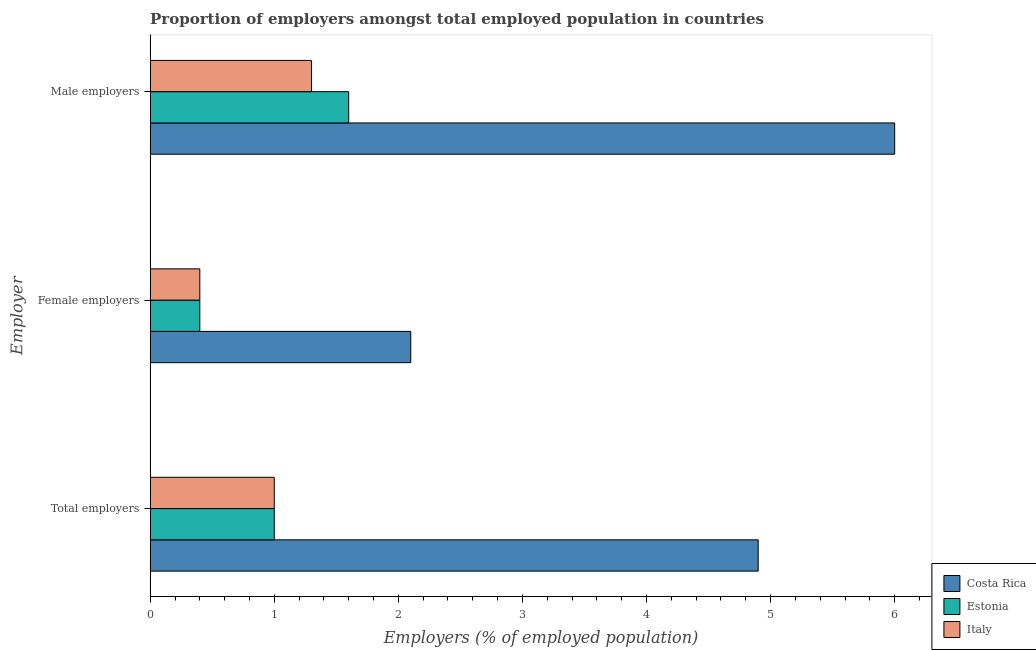How many different coloured bars are there?
Your response must be concise. 3. How many bars are there on the 2nd tick from the bottom?
Your answer should be very brief. 3. What is the label of the 1st group of bars from the top?
Your response must be concise. Male employers. What is the percentage of female employers in Estonia?
Your answer should be very brief. 0.4. Across all countries, what is the maximum percentage of female employers?
Keep it short and to the point. 2.1. Across all countries, what is the minimum percentage of male employers?
Ensure brevity in your answer.  1.3. In which country was the percentage of female employers maximum?
Offer a terse response. Costa Rica. In which country was the percentage of female employers minimum?
Offer a terse response. Estonia. What is the total percentage of male employers in the graph?
Keep it short and to the point. 8.9. What is the difference between the percentage of male employers in Italy and that in Estonia?
Ensure brevity in your answer.  -0.3. What is the difference between the percentage of female employers in Estonia and the percentage of male employers in Costa Rica?
Provide a short and direct response. -5.6. What is the average percentage of female employers per country?
Offer a terse response. 0.97. What is the difference between the percentage of total employers and percentage of female employers in Estonia?
Offer a terse response. 0.6. What is the difference between the highest and the second highest percentage of male employers?
Provide a succinct answer. 4.4. What is the difference between the highest and the lowest percentage of total employers?
Make the answer very short. 3.9. In how many countries, is the percentage of female employers greater than the average percentage of female employers taken over all countries?
Keep it short and to the point. 1. Is the sum of the percentage of female employers in Estonia and Costa Rica greater than the maximum percentage of total employers across all countries?
Provide a succinct answer. No. What does the 3rd bar from the top in Total employers represents?
Ensure brevity in your answer.  Costa Rica. What does the 2nd bar from the bottom in Total employers represents?
Give a very brief answer. Estonia. Are all the bars in the graph horizontal?
Keep it short and to the point. Yes. How many countries are there in the graph?
Your answer should be compact. 3. What is the difference between two consecutive major ticks on the X-axis?
Offer a terse response. 1. Are the values on the major ticks of X-axis written in scientific E-notation?
Offer a very short reply. No. Does the graph contain any zero values?
Your answer should be compact. No. Does the graph contain grids?
Provide a succinct answer. No. How many legend labels are there?
Ensure brevity in your answer.  3. What is the title of the graph?
Your answer should be very brief. Proportion of employers amongst total employed population in countries. Does "Tuvalu" appear as one of the legend labels in the graph?
Keep it short and to the point. No. What is the label or title of the X-axis?
Provide a succinct answer. Employers (% of employed population). What is the label or title of the Y-axis?
Your response must be concise. Employer. What is the Employers (% of employed population) in Costa Rica in Total employers?
Your answer should be very brief. 4.9. What is the Employers (% of employed population) of Costa Rica in Female employers?
Your answer should be compact. 2.1. What is the Employers (% of employed population) of Estonia in Female employers?
Make the answer very short. 0.4. What is the Employers (% of employed population) in Italy in Female employers?
Offer a very short reply. 0.4. What is the Employers (% of employed population) of Estonia in Male employers?
Your answer should be very brief. 1.6. What is the Employers (% of employed population) of Italy in Male employers?
Your answer should be compact. 1.3. Across all Employer, what is the maximum Employers (% of employed population) in Estonia?
Keep it short and to the point. 1.6. Across all Employer, what is the maximum Employers (% of employed population) in Italy?
Make the answer very short. 1.3. Across all Employer, what is the minimum Employers (% of employed population) in Costa Rica?
Your answer should be compact. 2.1. Across all Employer, what is the minimum Employers (% of employed population) of Estonia?
Provide a succinct answer. 0.4. Across all Employer, what is the minimum Employers (% of employed population) of Italy?
Give a very brief answer. 0.4. What is the total Employers (% of employed population) in Estonia in the graph?
Give a very brief answer. 3. What is the total Employers (% of employed population) in Italy in the graph?
Provide a short and direct response. 2.7. What is the difference between the Employers (% of employed population) of Estonia in Total employers and that in Female employers?
Offer a very short reply. 0.6. What is the difference between the Employers (% of employed population) in Italy in Total employers and that in Female employers?
Offer a terse response. 0.6. What is the difference between the Employers (% of employed population) of Costa Rica in Total employers and that in Male employers?
Give a very brief answer. -1.1. What is the difference between the Employers (% of employed population) of Estonia in Female employers and that in Male employers?
Provide a short and direct response. -1.2. What is the difference between the Employers (% of employed population) of Italy in Female employers and that in Male employers?
Give a very brief answer. -0.9. What is the difference between the Employers (% of employed population) in Costa Rica in Total employers and the Employers (% of employed population) in Estonia in Female employers?
Offer a terse response. 4.5. What is the difference between the Employers (% of employed population) of Estonia in Total employers and the Employers (% of employed population) of Italy in Female employers?
Ensure brevity in your answer.  0.6. What is the difference between the Employers (% of employed population) in Estonia in Total employers and the Employers (% of employed population) in Italy in Male employers?
Your answer should be compact. -0.3. What is the difference between the Employers (% of employed population) in Costa Rica in Female employers and the Employers (% of employed population) in Estonia in Male employers?
Your answer should be very brief. 0.5. What is the difference between the Employers (% of employed population) of Estonia in Female employers and the Employers (% of employed population) of Italy in Male employers?
Make the answer very short. -0.9. What is the average Employers (% of employed population) in Costa Rica per Employer?
Make the answer very short. 4.33. What is the average Employers (% of employed population) in Estonia per Employer?
Offer a terse response. 1. What is the average Employers (% of employed population) in Italy per Employer?
Provide a short and direct response. 0.9. What is the difference between the Employers (% of employed population) of Costa Rica and Employers (% of employed population) of Italy in Total employers?
Provide a short and direct response. 3.9. What is the difference between the Employers (% of employed population) of Costa Rica and Employers (% of employed population) of Italy in Female employers?
Give a very brief answer. 1.7. What is the difference between the Employers (% of employed population) of Costa Rica and Employers (% of employed population) of Italy in Male employers?
Offer a very short reply. 4.7. What is the difference between the Employers (% of employed population) in Estonia and Employers (% of employed population) in Italy in Male employers?
Offer a very short reply. 0.3. What is the ratio of the Employers (% of employed population) of Costa Rica in Total employers to that in Female employers?
Provide a succinct answer. 2.33. What is the ratio of the Employers (% of employed population) in Estonia in Total employers to that in Female employers?
Your answer should be compact. 2.5. What is the ratio of the Employers (% of employed population) of Italy in Total employers to that in Female employers?
Provide a short and direct response. 2.5. What is the ratio of the Employers (% of employed population) of Costa Rica in Total employers to that in Male employers?
Offer a terse response. 0.82. What is the ratio of the Employers (% of employed population) in Italy in Total employers to that in Male employers?
Make the answer very short. 0.77. What is the ratio of the Employers (% of employed population) of Costa Rica in Female employers to that in Male employers?
Your answer should be compact. 0.35. What is the ratio of the Employers (% of employed population) of Estonia in Female employers to that in Male employers?
Make the answer very short. 0.25. What is the ratio of the Employers (% of employed population) of Italy in Female employers to that in Male employers?
Offer a very short reply. 0.31. What is the difference between the highest and the second highest Employers (% of employed population) of Costa Rica?
Offer a terse response. 1.1. What is the difference between the highest and the second highest Employers (% of employed population) of Estonia?
Offer a terse response. 0.6. What is the difference between the highest and the lowest Employers (% of employed population) of Italy?
Provide a succinct answer. 0.9. 